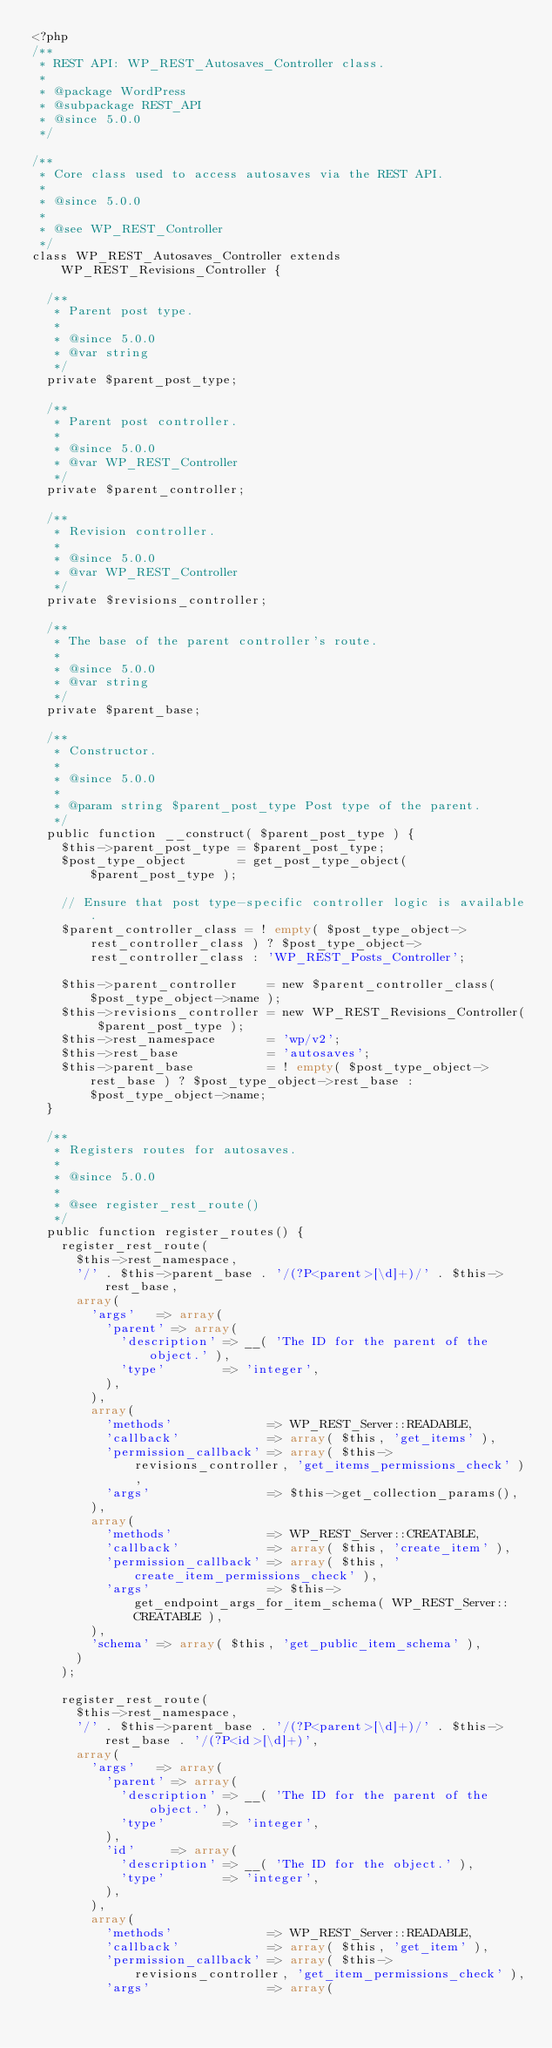Convert code to text. <code><loc_0><loc_0><loc_500><loc_500><_PHP_><?php
/**
 * REST API: WP_REST_Autosaves_Controller class.
 *
 * @package WordPress
 * @subpackage REST_API
 * @since 5.0.0
 */

/**
 * Core class used to access autosaves via the REST API.
 *
 * @since 5.0.0
 *
 * @see WP_REST_Controller
 */
class WP_REST_Autosaves_Controller extends WP_REST_Revisions_Controller {

	/**
	 * Parent post type.
	 *
	 * @since 5.0.0
	 * @var string
	 */
	private $parent_post_type;

	/**
	 * Parent post controller.
	 *
	 * @since 5.0.0
	 * @var WP_REST_Controller
	 */
	private $parent_controller;

	/**
	 * Revision controller.
	 *
	 * @since 5.0.0
	 * @var WP_REST_Controller
	 */
	private $revisions_controller;

	/**
	 * The base of the parent controller's route.
	 *
	 * @since 5.0.0
	 * @var string
	 */
	private $parent_base;

	/**
	 * Constructor.
	 *
	 * @since 5.0.0
	 *
	 * @param string $parent_post_type Post type of the parent.
	 */
	public function __construct( $parent_post_type ) {
		$this->parent_post_type = $parent_post_type;
		$post_type_object       = get_post_type_object( $parent_post_type );

		// Ensure that post type-specific controller logic is available.
		$parent_controller_class = ! empty( $post_type_object->rest_controller_class ) ? $post_type_object->rest_controller_class : 'WP_REST_Posts_Controller';

		$this->parent_controller    = new $parent_controller_class( $post_type_object->name );
		$this->revisions_controller = new WP_REST_Revisions_Controller( $parent_post_type );
		$this->rest_namespace       = 'wp/v2';
		$this->rest_base            = 'autosaves';
		$this->parent_base          = ! empty( $post_type_object->rest_base ) ? $post_type_object->rest_base : $post_type_object->name;
	}

	/**
	 * Registers routes for autosaves.
	 *
	 * @since 5.0.0
	 *
	 * @see register_rest_route()
	 */
	public function register_routes() {
		register_rest_route(
			$this->rest_namespace,
			'/' . $this->parent_base . '/(?P<parent>[\d]+)/' . $this->rest_base,
			array(
				'args'   => array(
					'parent' => array(
						'description' => __( 'The ID for the parent of the object.' ),
						'type'        => 'integer',
					),
				),
				array(
					'methods'             => WP_REST_Server::READABLE,
					'callback'            => array( $this, 'get_items' ),
					'permission_callback' => array( $this->revisions_controller, 'get_items_permissions_check' ),
					'args'                => $this->get_collection_params(),
				),
				array(
					'methods'             => WP_REST_Server::CREATABLE,
					'callback'            => array( $this, 'create_item' ),
					'permission_callback' => array( $this, 'create_item_permissions_check' ),
					'args'                => $this->get_endpoint_args_for_item_schema( WP_REST_Server::CREATABLE ),
				),
				'schema' => array( $this, 'get_public_item_schema' ),
			)
		);

		register_rest_route(
			$this->rest_namespace,
			'/' . $this->parent_base . '/(?P<parent>[\d]+)/' . $this->rest_base . '/(?P<id>[\d]+)',
			array(
				'args'   => array(
					'parent' => array(
						'description' => __( 'The ID for the parent of the object.' ),
						'type'        => 'integer',
					),
					'id'     => array(
						'description' => __( 'The ID for the object.' ),
						'type'        => 'integer',
					),
				),
				array(
					'methods'             => WP_REST_Server::READABLE,
					'callback'            => array( $this, 'get_item' ),
					'permission_callback' => array( $this->revisions_controller, 'get_item_permissions_check' ),
					'args'                => array(</code> 